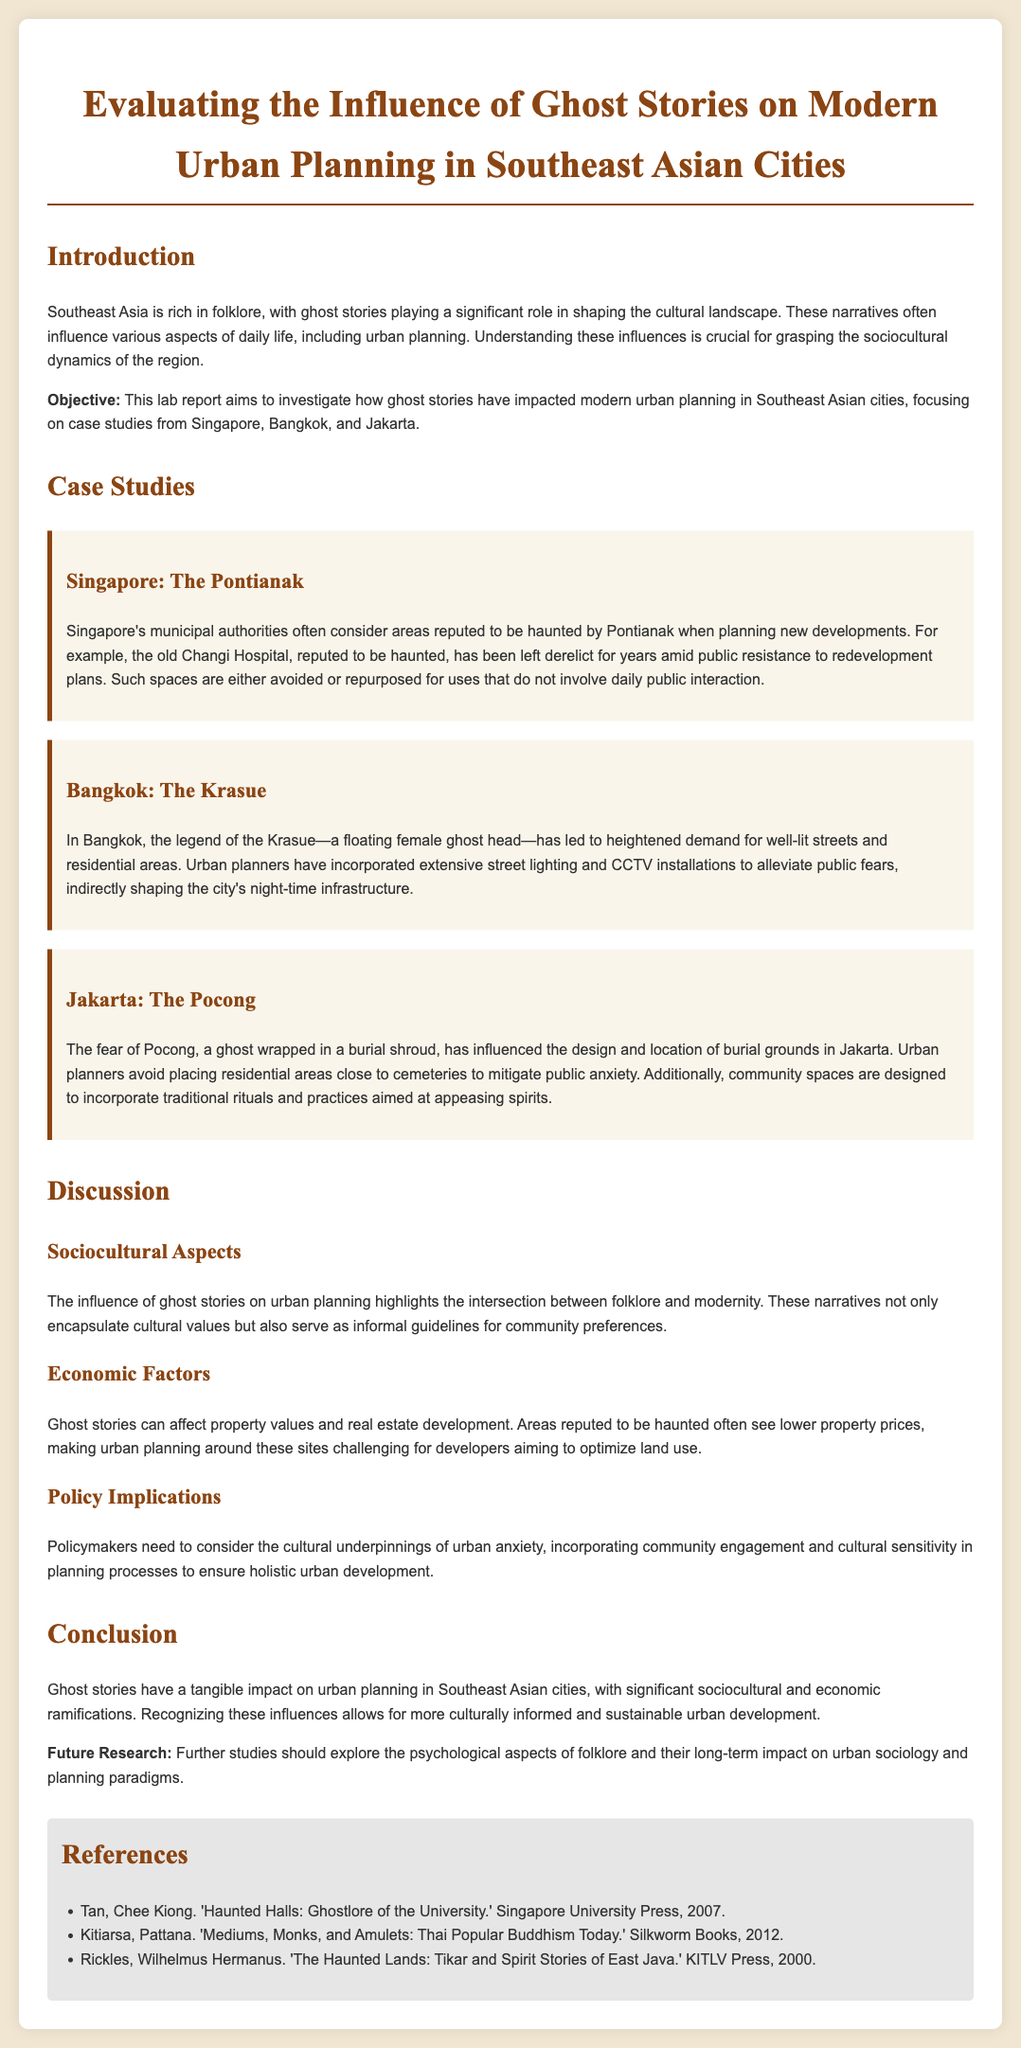What is the main objective of the lab report? The objective is to investigate how ghost stories have impacted modern urban planning in Southeast Asian cities.
Answer: To investigate how ghost stories have impacted modern urban planning in Southeast Asian cities Which ghost is associated with Singapore in the report? The report mentions the Pontianak as the ghost associated with Singapore.
Answer: Pontianak What has influenced the design of residential areas in Bangkok? The Krasue legend has led to heightened demand for well-lit streets and residential areas.
Answer: Well-lit streets and residential areas What is one of the cultural factors that influence urban planning according to the document? The document states that folklore serves as informal guidelines for community preferences.
Answer: Informal guidelines for community preferences What is a key policy implication stated in the report? Policymakers need to consider cultural underpinnings of urban anxiety.
Answer: Cultural underpinnings of urban anxiety How many case studies are included in the lab report? The document discusses three case studies from Singapore, Bangkok, and Jakarta.
Answer: Three Who authored the book "Haunted Halls: Ghostlore of the University"? The author of that book is Tan, Chee Kiong.
Answer: Tan, Chee Kiong What is suggested for future research in the conclusion? The report suggests exploring the psychological aspects of folklore and their long-term impact.
Answer: Psychological aspects of folklore and their long-term impact In which city does the influence of the Pocong ghost manifest? The influence of the Pocong is discussed in relation to Jakarta.
Answer: Jakarta 